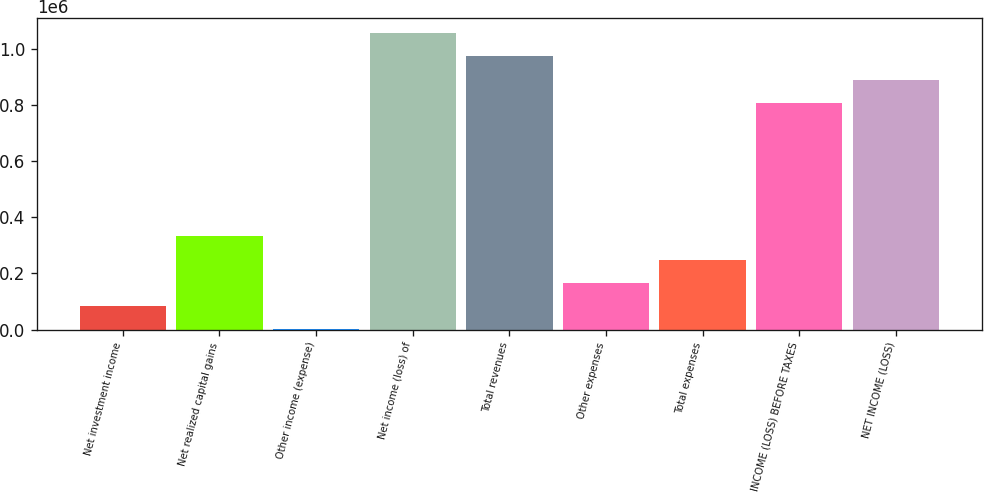<chart> <loc_0><loc_0><loc_500><loc_500><bar_chart><fcel>Net investment income<fcel>Net realized capital gains<fcel>Other income (expense)<fcel>Net income (loss) of<fcel>Total revenues<fcel>Other expenses<fcel>Total expenses<fcel>INCOME (LOSS) BEFORE TAXES<fcel>NET INCOME (LOSS)<nl><fcel>83298.9<fcel>331978<fcel>406<fcel>1.05567e+06<fcel>972774<fcel>166192<fcel>249085<fcel>806988<fcel>889881<nl></chart> 